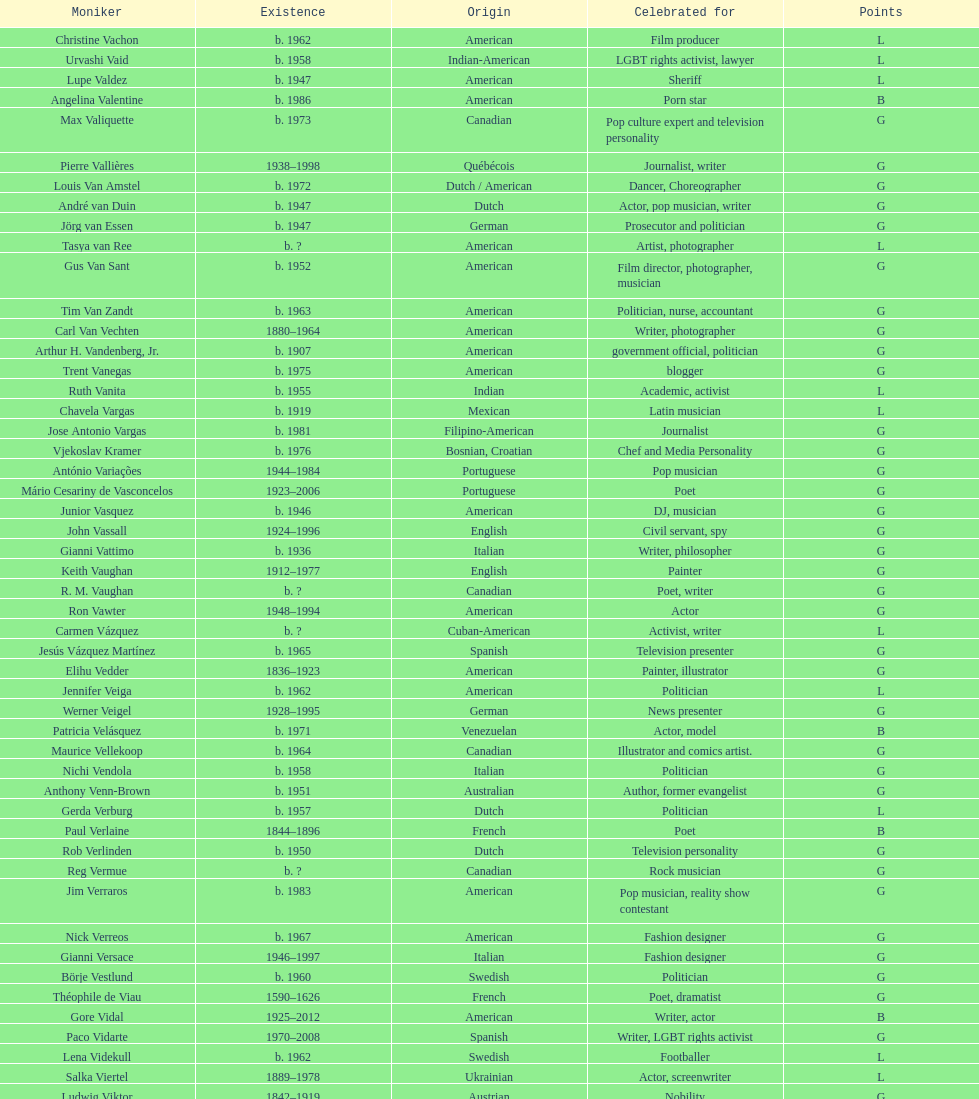Who was canadian, van amstel or valiquette? Valiquette. 